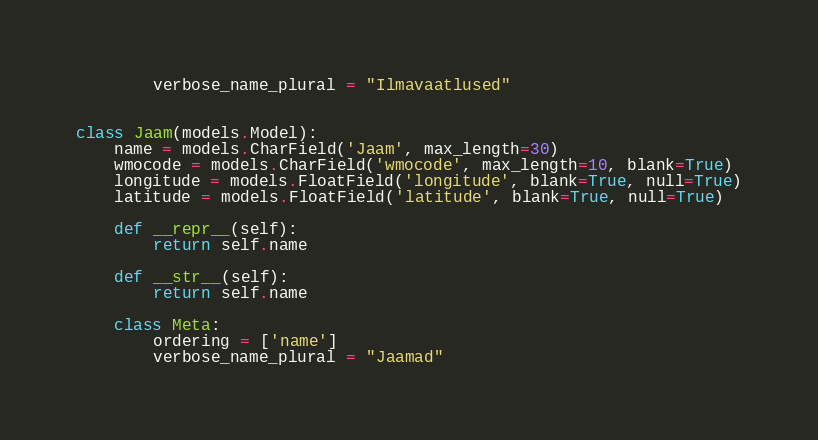Convert code to text. <code><loc_0><loc_0><loc_500><loc_500><_Python_>        verbose_name_plural = "Ilmavaatlused"


class Jaam(models.Model):
    name = models.CharField('Jaam', max_length=30)
    wmocode = models.CharField('wmocode', max_length=10, blank=True)
    longitude = models.FloatField('longitude', blank=True, null=True)
    latitude = models.FloatField('latitude', blank=True, null=True)

    def __repr__(self):
        return self.name

    def __str__(self):
        return self.name

    class Meta:
        ordering = ['name']
        verbose_name_plural = "Jaamad"</code> 